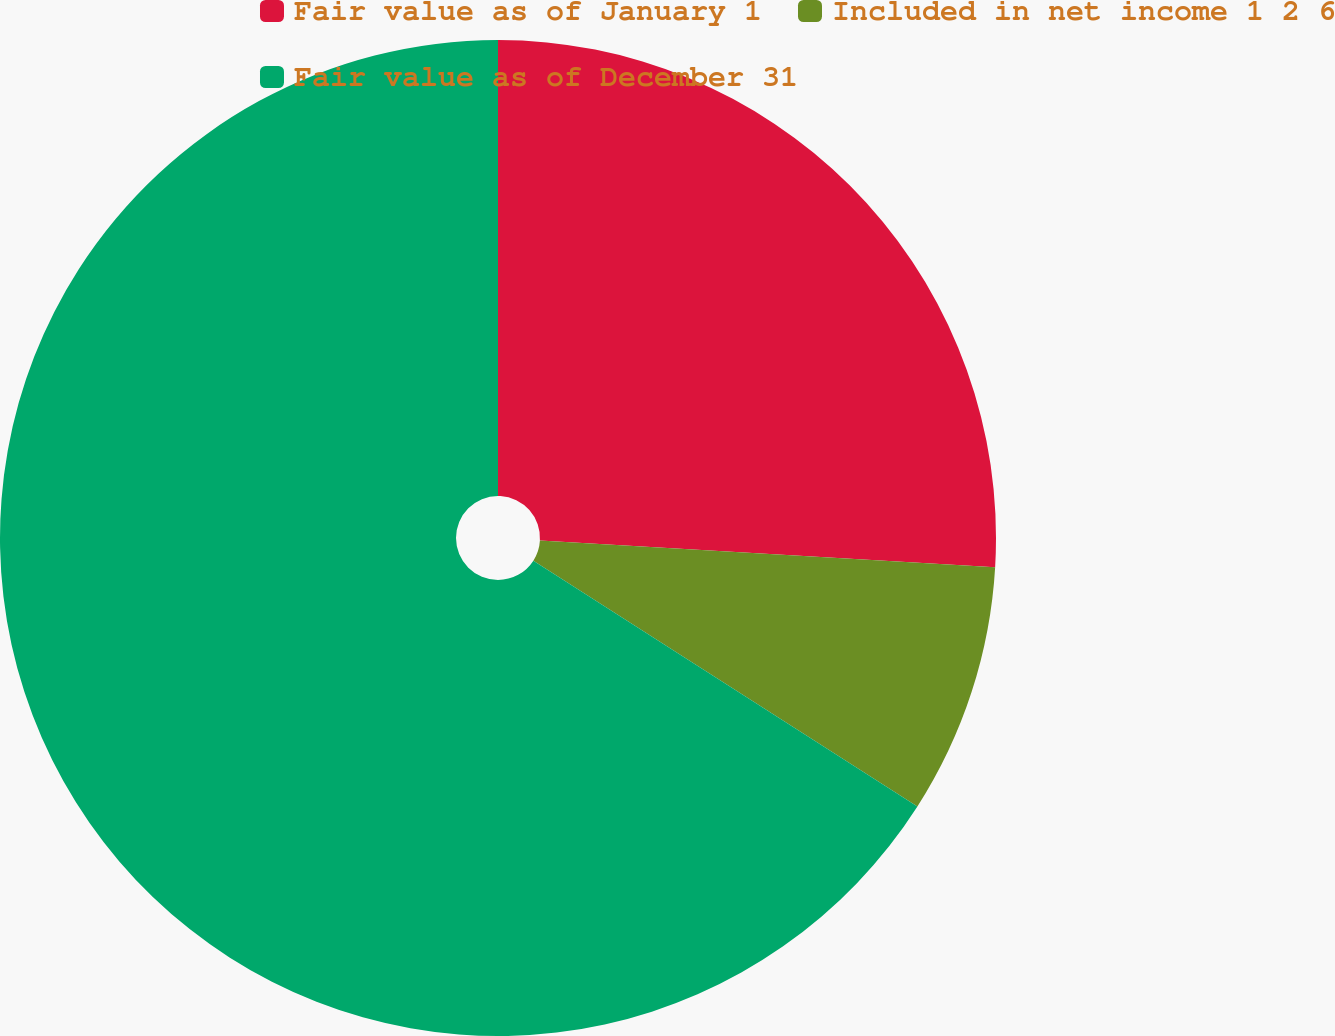Convert chart to OTSL. <chart><loc_0><loc_0><loc_500><loc_500><pie_chart><fcel>Fair value as of January 1<fcel>Included in net income 1 2 6<fcel>Fair value as of December 31<nl><fcel>25.93%<fcel>8.13%<fcel>65.93%<nl></chart> 